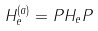<formula> <loc_0><loc_0><loc_500><loc_500>H _ { e } ^ { ( a ) } = P H _ { e } P</formula> 